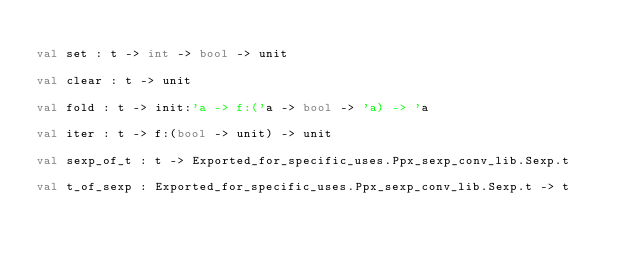Convert code to text. <code><loc_0><loc_0><loc_500><loc_500><_OCaml_>
val set : t -> int -> bool -> unit

val clear : t -> unit

val fold : t -> init:'a -> f:('a -> bool -> 'a) -> 'a

val iter : t -> f:(bool -> unit) -> unit

val sexp_of_t : t -> Exported_for_specific_uses.Ppx_sexp_conv_lib.Sexp.t

val t_of_sexp : Exported_for_specific_uses.Ppx_sexp_conv_lib.Sexp.t -> t
</code> 